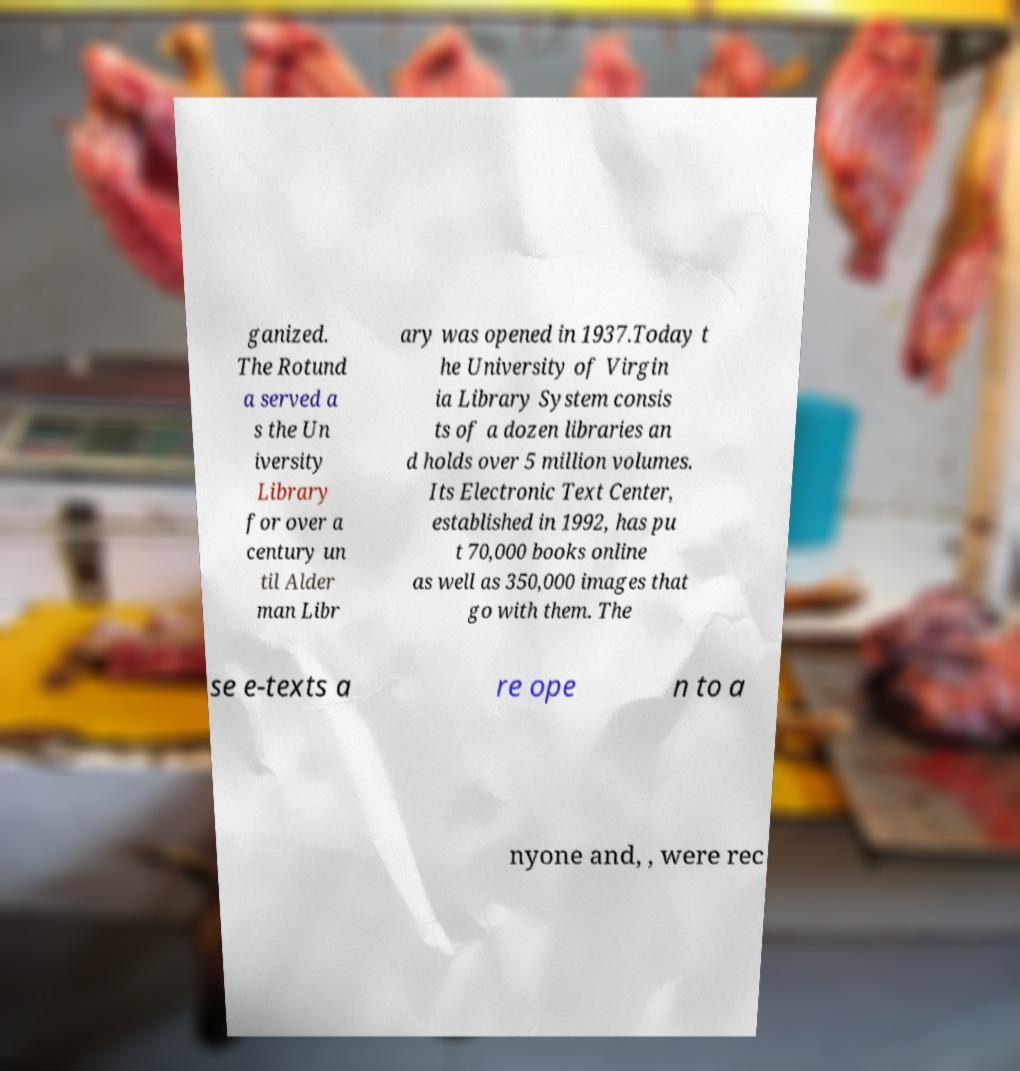Please identify and transcribe the text found in this image. ganized. The Rotund a served a s the Un iversity Library for over a century un til Alder man Libr ary was opened in 1937.Today t he University of Virgin ia Library System consis ts of a dozen libraries an d holds over 5 million volumes. Its Electronic Text Center, established in 1992, has pu t 70,000 books online as well as 350,000 images that go with them. The se e-texts a re ope n to a nyone and, , were rec 